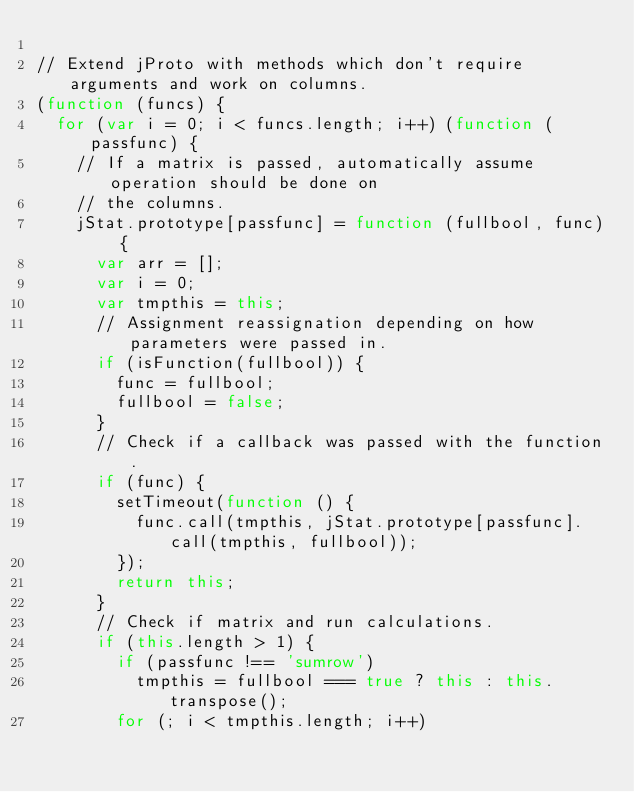<code> <loc_0><loc_0><loc_500><loc_500><_JavaScript_>
// Extend jProto with methods which don't require arguments and work on columns.
(function (funcs) {
  for (var i = 0; i < funcs.length; i++) (function (passfunc) {
    // If a matrix is passed, automatically assume operation should be done on
    // the columns.
    jStat.prototype[passfunc] = function (fullbool, func) {
      var arr = [];
      var i = 0;
      var tmpthis = this;
      // Assignment reassignation depending on how parameters were passed in.
      if (isFunction(fullbool)) {
        func = fullbool;
        fullbool = false;
      }
      // Check if a callback was passed with the function.
      if (func) {
        setTimeout(function () {
          func.call(tmpthis, jStat.prototype[passfunc].call(tmpthis, fullbool));
        });
        return this;
      }
      // Check if matrix and run calculations.
      if (this.length > 1) {
        if (passfunc !== 'sumrow')
          tmpthis = fullbool === true ? this : this.transpose();
        for (; i < tmpthis.length; i++)</code> 